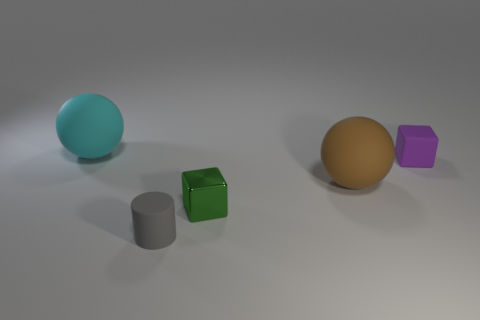The cyan thing has what size?
Your answer should be compact. Large. There is a cube behind the tiny green cube; is its size the same as the matte sphere behind the brown matte thing?
Offer a terse response. No. The large thing that is to the right of the big rubber thing behind the large brown object is what color?
Keep it short and to the point. Brown. There is another ball that is the same size as the cyan rubber sphere; what is it made of?
Keep it short and to the point. Rubber. How many shiny things are either purple objects or tiny red balls?
Your answer should be compact. 0. The matte thing that is both on the left side of the small metallic cube and behind the tiny gray rubber cylinder is what color?
Ensure brevity in your answer.  Cyan. How many cyan balls are on the right side of the brown rubber ball?
Ensure brevity in your answer.  0. What material is the small purple object?
Ensure brevity in your answer.  Rubber. What is the color of the big matte sphere that is to the right of the tiny green cube that is left of the ball on the right side of the small matte cylinder?
Provide a short and direct response. Brown. What number of brown rubber things have the same size as the cyan object?
Keep it short and to the point. 1. 